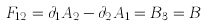<formula> <loc_0><loc_0><loc_500><loc_500>F _ { 1 2 } = \partial _ { 1 } A _ { 2 } - \partial _ { 2 } A _ { 1 } = B _ { 3 } = B</formula> 